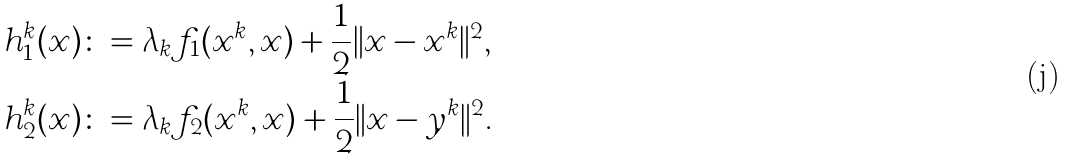Convert formula to latex. <formula><loc_0><loc_0><loc_500><loc_500>h _ { 1 } ^ { k } ( x ) & \colon = \lambda _ { k } f _ { 1 } ( x ^ { k } , x ) + \frac { 1 } { 2 } \| x - x ^ { k } \| ^ { 2 } , \\ h _ { 2 } ^ { k } ( x ) & \colon = \lambda _ { k } f _ { 2 } ( x ^ { k } , x ) + \frac { 1 } { 2 } \| x - y ^ { k } \| ^ { 2 } .</formula> 